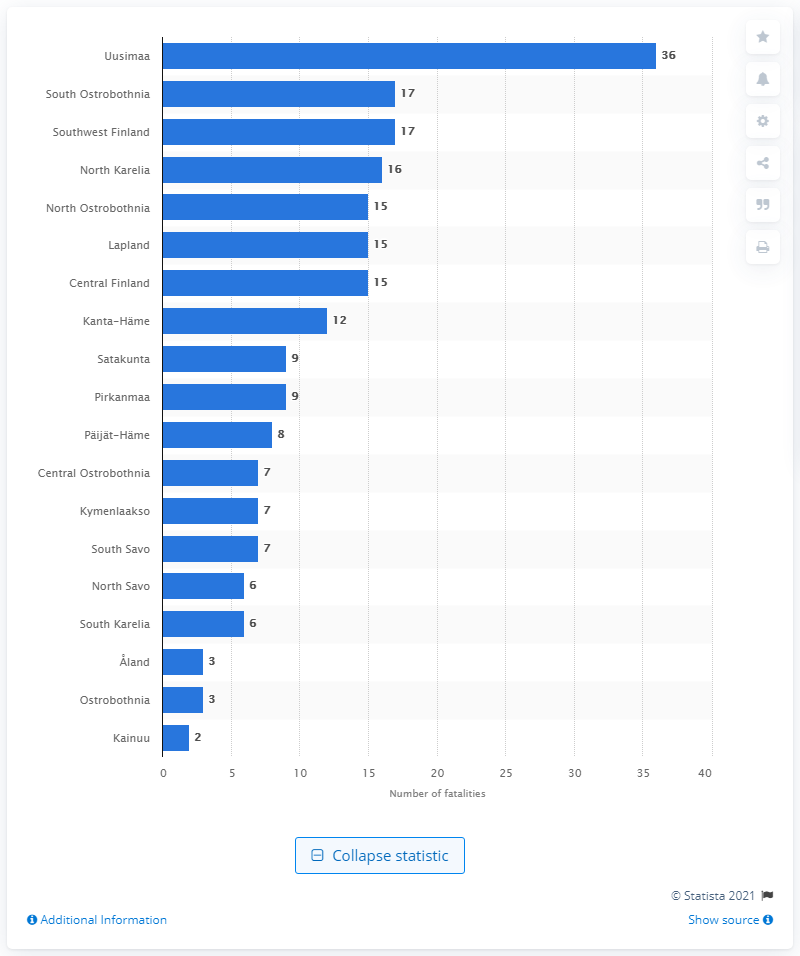Specify some key components in this picture. In 2019, a total of 17 road casualties occurred in South Ostrobothnia. In 2019, there were 36 road casualties in the capital region of Uusimaa. 